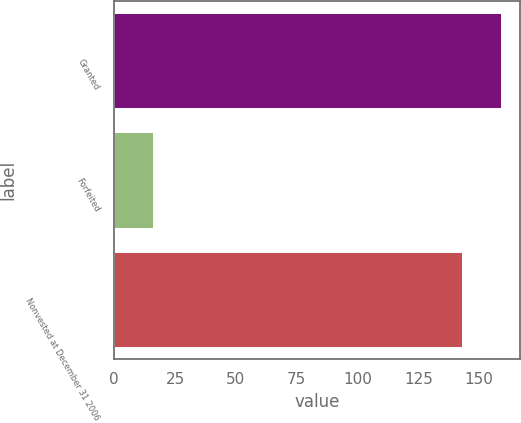<chart> <loc_0><loc_0><loc_500><loc_500><bar_chart><fcel>Granted<fcel>Forfeited<fcel>Nonvested at December 31 2006<nl><fcel>159<fcel>16<fcel>143<nl></chart> 